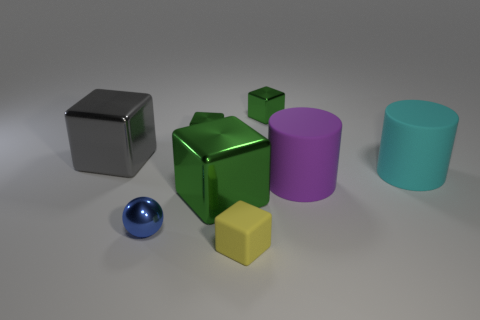Subtract all small yellow blocks. How many blocks are left? 4 Subtract all gray cubes. How many cubes are left? 4 Add 2 balls. How many objects exist? 10 Subtract 3 blocks. How many blocks are left? 2 Subtract 0 green cylinders. How many objects are left? 8 Subtract all spheres. How many objects are left? 7 Subtract all purple blocks. Subtract all blue spheres. How many blocks are left? 5 Subtract all brown cylinders. How many gray cubes are left? 1 Subtract all rubber things. Subtract all big gray shiny things. How many objects are left? 4 Add 2 gray things. How many gray things are left? 3 